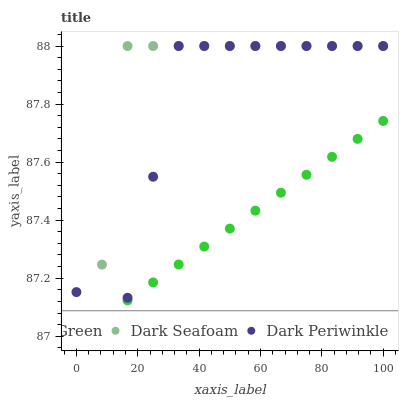Does Lime Green have the minimum area under the curve?
Answer yes or no. Yes. Does Dark Seafoam have the maximum area under the curve?
Answer yes or no. Yes. Does Dark Periwinkle have the minimum area under the curve?
Answer yes or no. No. Does Dark Periwinkle have the maximum area under the curve?
Answer yes or no. No. Is Lime Green the smoothest?
Answer yes or no. Yes. Is Dark Seafoam the roughest?
Answer yes or no. Yes. Is Dark Periwinkle the smoothest?
Answer yes or no. No. Is Dark Periwinkle the roughest?
Answer yes or no. No. Does Lime Green have the lowest value?
Answer yes or no. Yes. Does Dark Periwinkle have the lowest value?
Answer yes or no. No. Does Dark Periwinkle have the highest value?
Answer yes or no. Yes. Does Lime Green have the highest value?
Answer yes or no. No. Is Lime Green less than Dark Seafoam?
Answer yes or no. Yes. Is Dark Seafoam greater than Lime Green?
Answer yes or no. Yes. Does Dark Periwinkle intersect Dark Seafoam?
Answer yes or no. Yes. Is Dark Periwinkle less than Dark Seafoam?
Answer yes or no. No. Is Dark Periwinkle greater than Dark Seafoam?
Answer yes or no. No. Does Lime Green intersect Dark Seafoam?
Answer yes or no. No. 